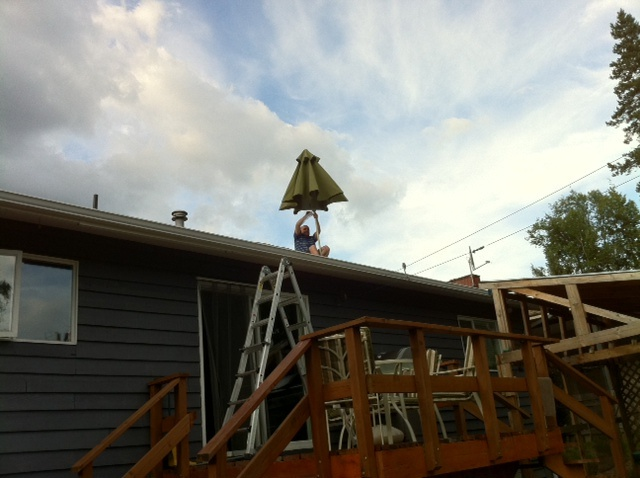Describe the objects in this image and their specific colors. I can see chair in darkgray, black, darkgreen, and gray tones, umbrella in darkgray, black, darkgreen, and gray tones, chair in darkgray, black, darkgreen, and gray tones, chair in darkgray, black, darkgreen, and gray tones, and people in darkgray, black, and gray tones in this image. 